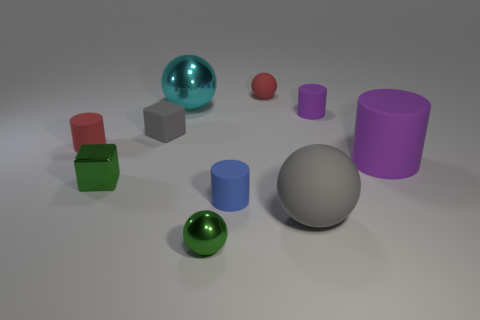What is the size of the red object that is the same shape as the tiny blue thing?
Your answer should be compact. Small. The small gray rubber object has what shape?
Provide a succinct answer. Cube. Does the cyan ball have the same material as the tiny green object in front of the large gray sphere?
Give a very brief answer. Yes. How many rubber things are big brown cylinders or green blocks?
Provide a short and direct response. 0. There is a red thing to the right of the green shiny ball; how big is it?
Ensure brevity in your answer.  Small. What size is the other ball that is the same material as the cyan ball?
Keep it short and to the point. Small. What number of tiny objects have the same color as the small shiny sphere?
Offer a terse response. 1. Are any small blue rubber cylinders visible?
Offer a very short reply. Yes. Does the large purple matte thing have the same shape as the small red matte thing right of the small blue rubber cylinder?
Your answer should be compact. No. The tiny block that is behind the small red rubber thing that is to the left of the cyan sphere on the right side of the red cylinder is what color?
Provide a short and direct response. Gray. 